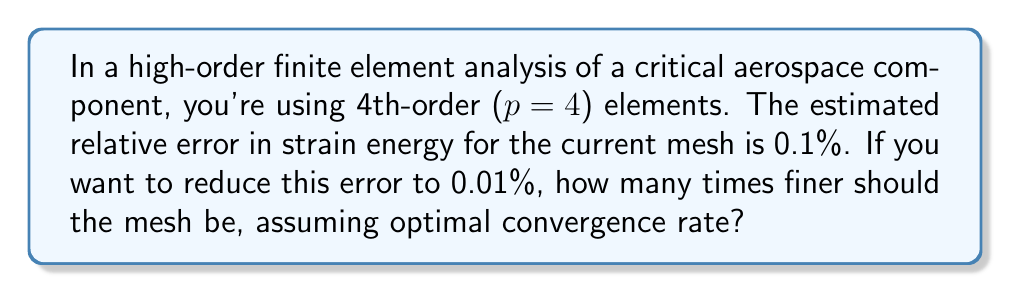Help me with this question. To solve this problem, we'll follow these steps:

1) Recall the convergence rate formula for finite element methods:
   $$e \approx Ch^{p+1}$$
   where $e$ is the error, $C$ is a constant, $h$ is the mesh size, and $p$ is the polynomial order.

2) For 4th-order elements, $p = 4$, so the convergence rate is $h^5$.

3) Let's define:
   $e_1 = 0.1\%$ (current error)
   $e_2 = 0.01\%$ (desired error)
   $h_1$ = current mesh size
   $h_2$ = required mesh size

4) We can write:
   $$e_1 = Ch_1^5$$
   $$e_2 = Ch_2^5$$

5) Dividing these equations:
   $$\frac{e_2}{e_1} = \frac{Ch_2^5}{Ch_1^5} = \left(\frac{h_2}{h_1}\right)^5$$

6) Substituting the known error values:
   $$\frac{0.01\%}{0.1\%} = \left(\frac{h_2}{h_1}\right)^5$$

7) Simplifying:
   $$0.1 = \left(\frac{h_2}{h_1}\right)^5$$

8) Taking the fifth root of both sides:
   $$0.1^{1/5} = \frac{h_2}{h_1}$$

9) Calculate:
   $$\frac{h_2}{h_1} \approx 0.63$$

10) The refinement factor is the inverse of this ratio:
    $$\text{Refinement factor} = \frac{h_1}{h_2} = \frac{1}{0.63} \approx 1.58$$

Therefore, the mesh should be approximately 1.58 times finer in each direction.
Answer: 1.58 times finer 